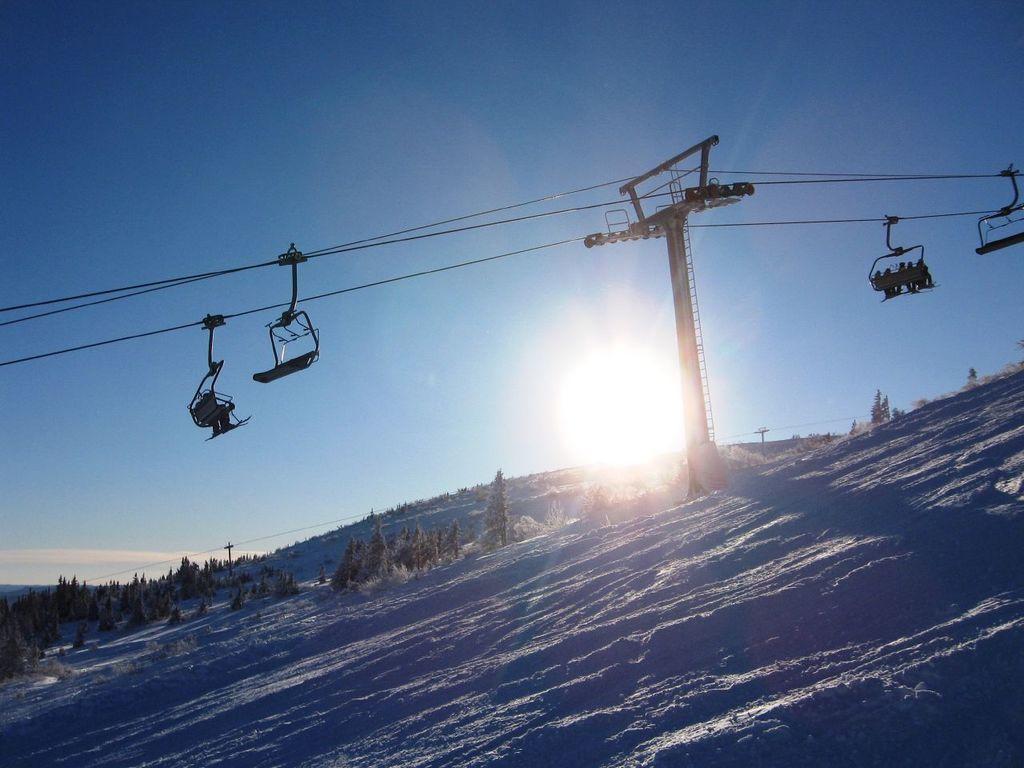In one or two sentences, can you explain what this image depicts? In this image I see the snow and I see pole over here and I see the wires on which there are ropeways and I see few persons sitting on it. In the background I see the trees and I see the sky and I see the sun over here. 